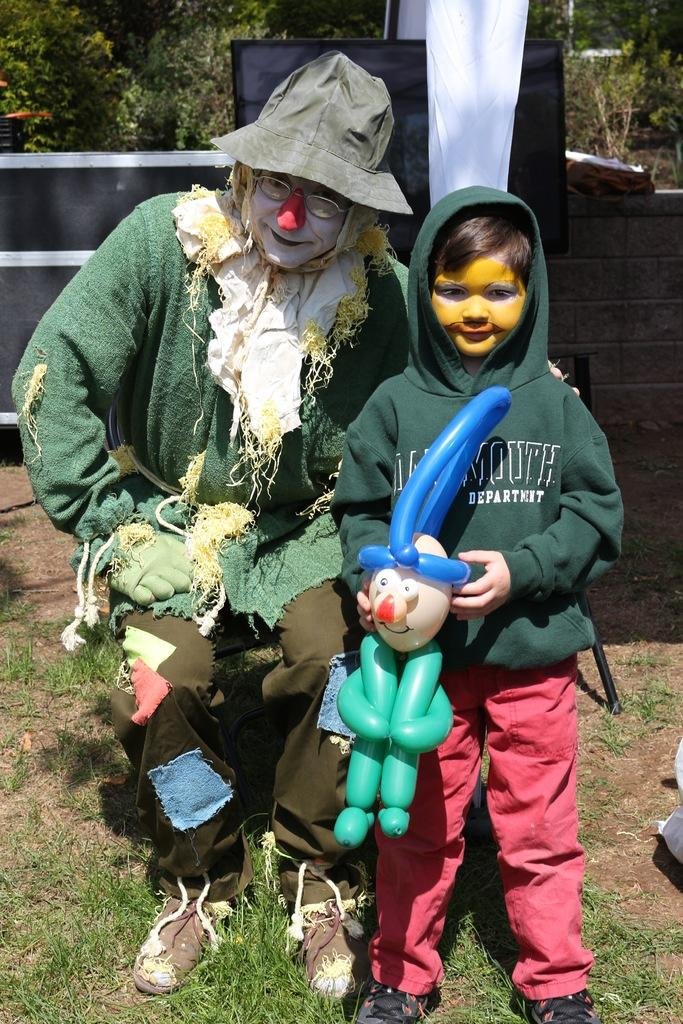Who is present in the image? There is a person and a boy in the image. What is the boy holding in the image? The boy is holding a balloon. How are the faces of the person and boy in the image? The faces of the person and boy have paint on them. What can be seen in the background of the image? There is a wall, a screen, and plants in the background of the image. What type of surface is visible in the image? There is grass in the image. What type of note is the boy playing on in the image? There is no note or musical instrument present in the image; the boy is holding a balloon. Can you see a donkey in the image? No, there is no donkey present in the image. 